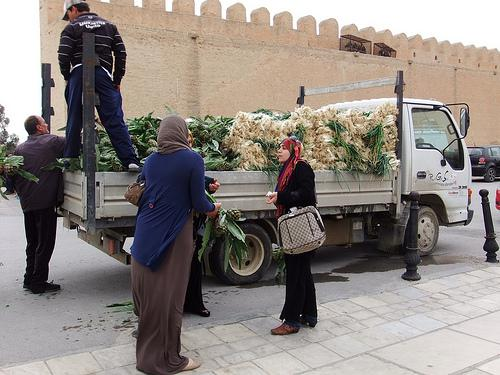Question: what is mostly red?
Choices:
A. A sweater.
B. A rug.
C. A head scarf.
D. A couch.
Answer with the letter. Answer: C Question: why are their leaves on the road?
Choices:
A. They've fallen from the trees.
B. Kids threw it on the streets.
C. The wind blew it on the streets.
D. They've fallen from the truck.
Answer with the letter. Answer: D 